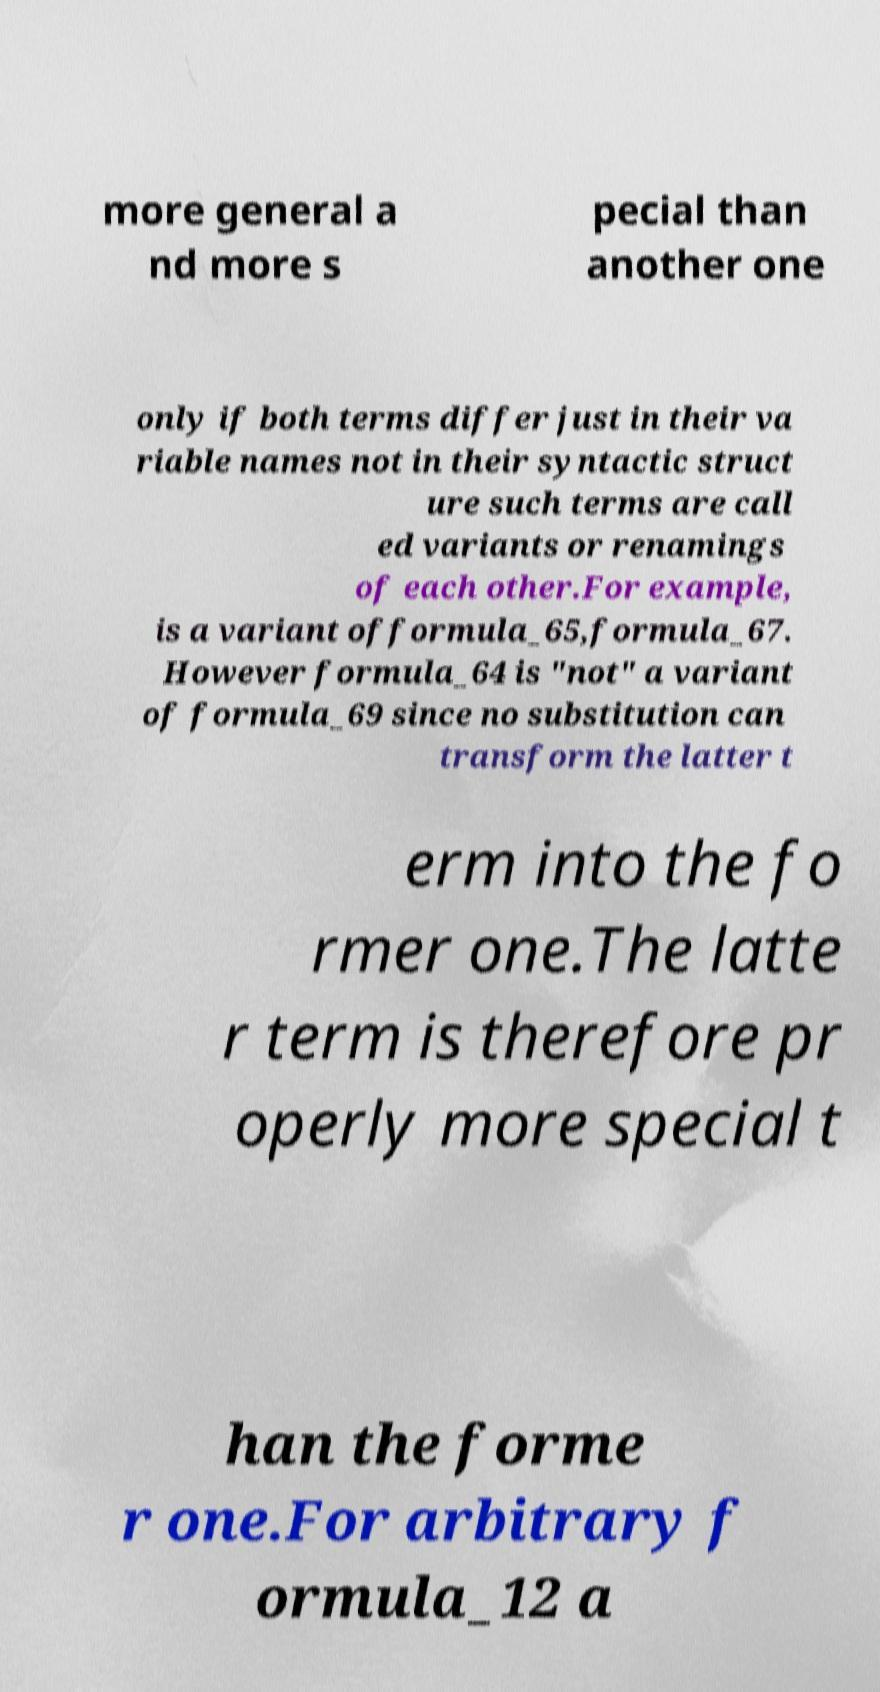What messages or text are displayed in this image? I need them in a readable, typed format. more general a nd more s pecial than another one only if both terms differ just in their va riable names not in their syntactic struct ure such terms are call ed variants or renamings of each other.For example, is a variant offormula_65,formula_67. However formula_64 is "not" a variant of formula_69 since no substitution can transform the latter t erm into the fo rmer one.The latte r term is therefore pr operly more special t han the forme r one.For arbitrary f ormula_12 a 